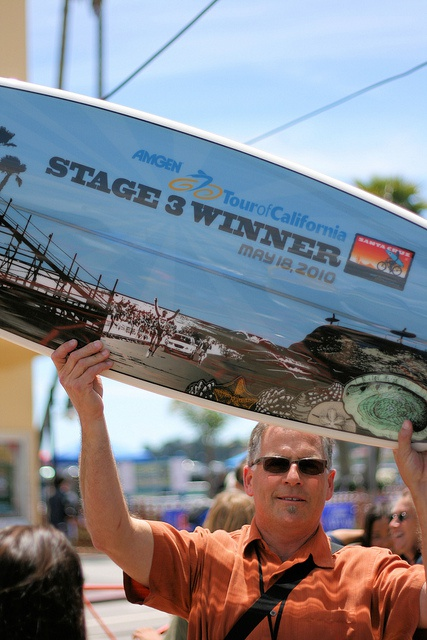Describe the objects in this image and their specific colors. I can see surfboard in tan, gray, black, and darkgray tones, people in tan, brown, and maroon tones, people in tan, black, gray, and darkgray tones, people in tan, brown, and maroon tones, and people in tan, black, gray, and maroon tones in this image. 